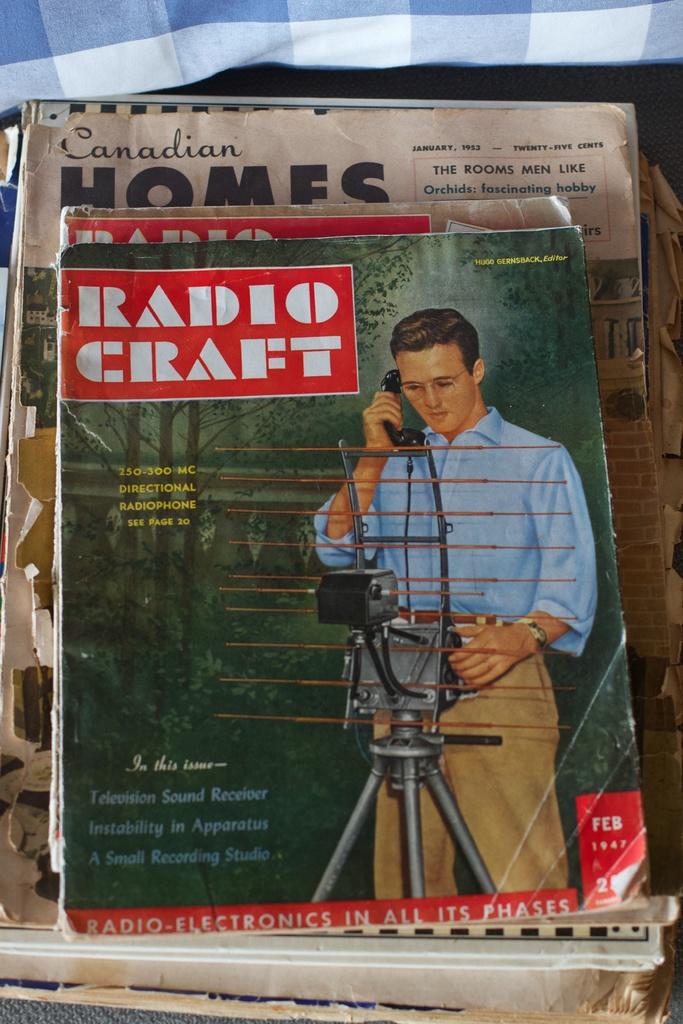What kind of craft is this magazine for?
Your answer should be very brief. Radio. What is the country name written beside the magazine?
Give a very brief answer. Canada. 